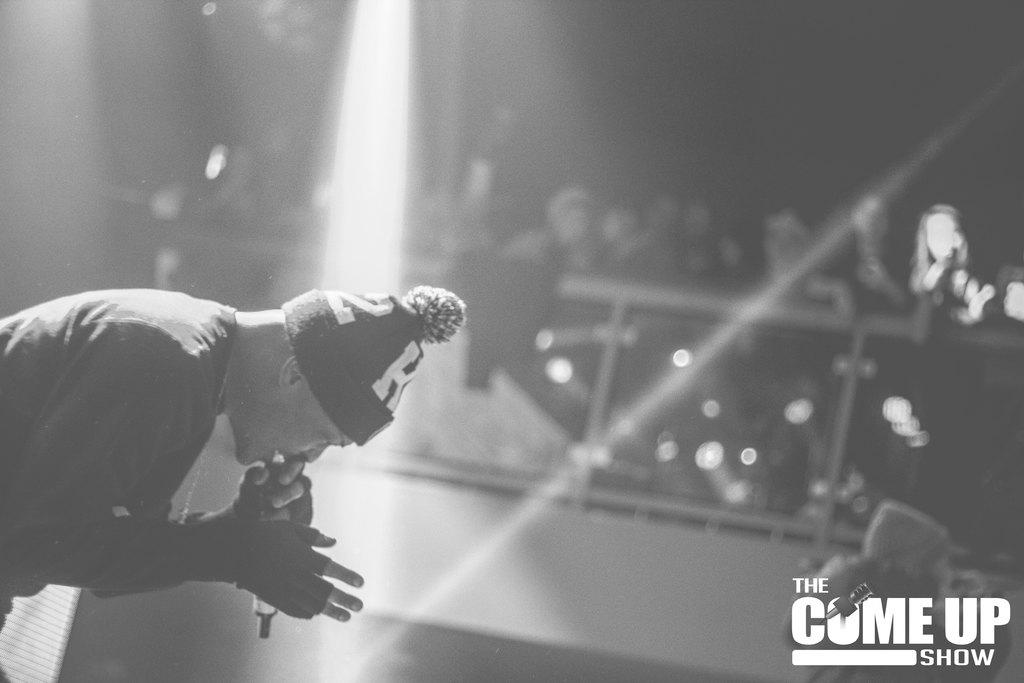What is the main subject of the image? The main subject of the image is a man. What is the man doing in the image? The man is singing in the image. Can you describe the man's attire? The man is wearing a cap in the image. What are the other people in the image doing? The other people are standing and observing the man in the image. What type of pie is being served to the quartz in the image? There is no pie or quartz present in the image. How many clocks are visible on the man's cap in the image? There are no clocks visible on the man's cap in the image. 